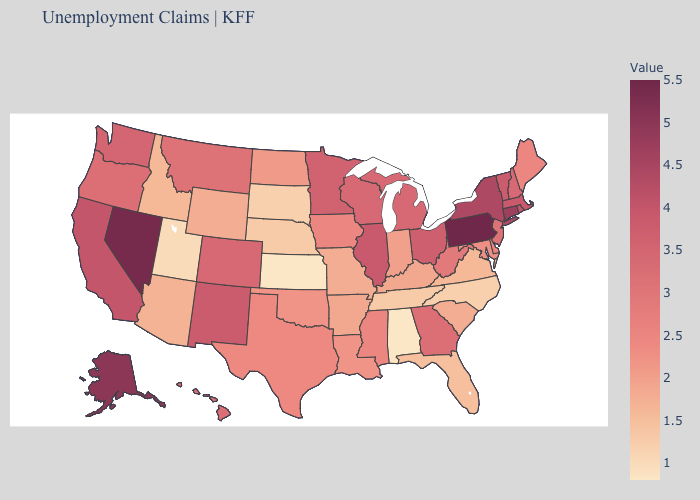Among the states that border Massachusetts , does Vermont have the lowest value?
Concise answer only. No. Which states have the lowest value in the West?
Be succinct. Utah. Does Florida have a higher value than Maine?
Be succinct. No. Among the states that border Idaho , does Nevada have the highest value?
Write a very short answer. Yes. Which states have the lowest value in the USA?
Be succinct. Alabama, Kansas. Does Illinois have the highest value in the MidWest?
Write a very short answer. Yes. Does Pennsylvania have the highest value in the USA?
Be succinct. Yes. 